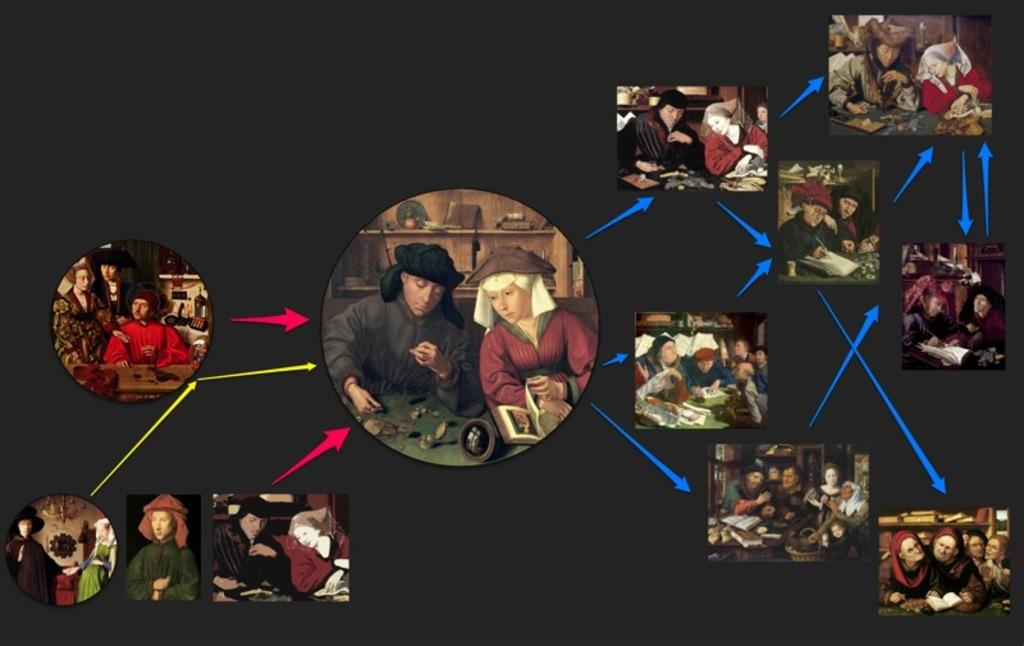What type of image is shown in the picture? The image is edited and contains animated images. How are the animated images arranged in the image? The animated images are arranged in a specific order. What can be seen pointing towards the pictures in the image? There are arrows pointing towards the pictures in the image. What time of day is depicted in the image? The image does not depict a specific time of day, as it is an edited image with animated elements. Can you see a horse in the image? There is no horse present in the image. 